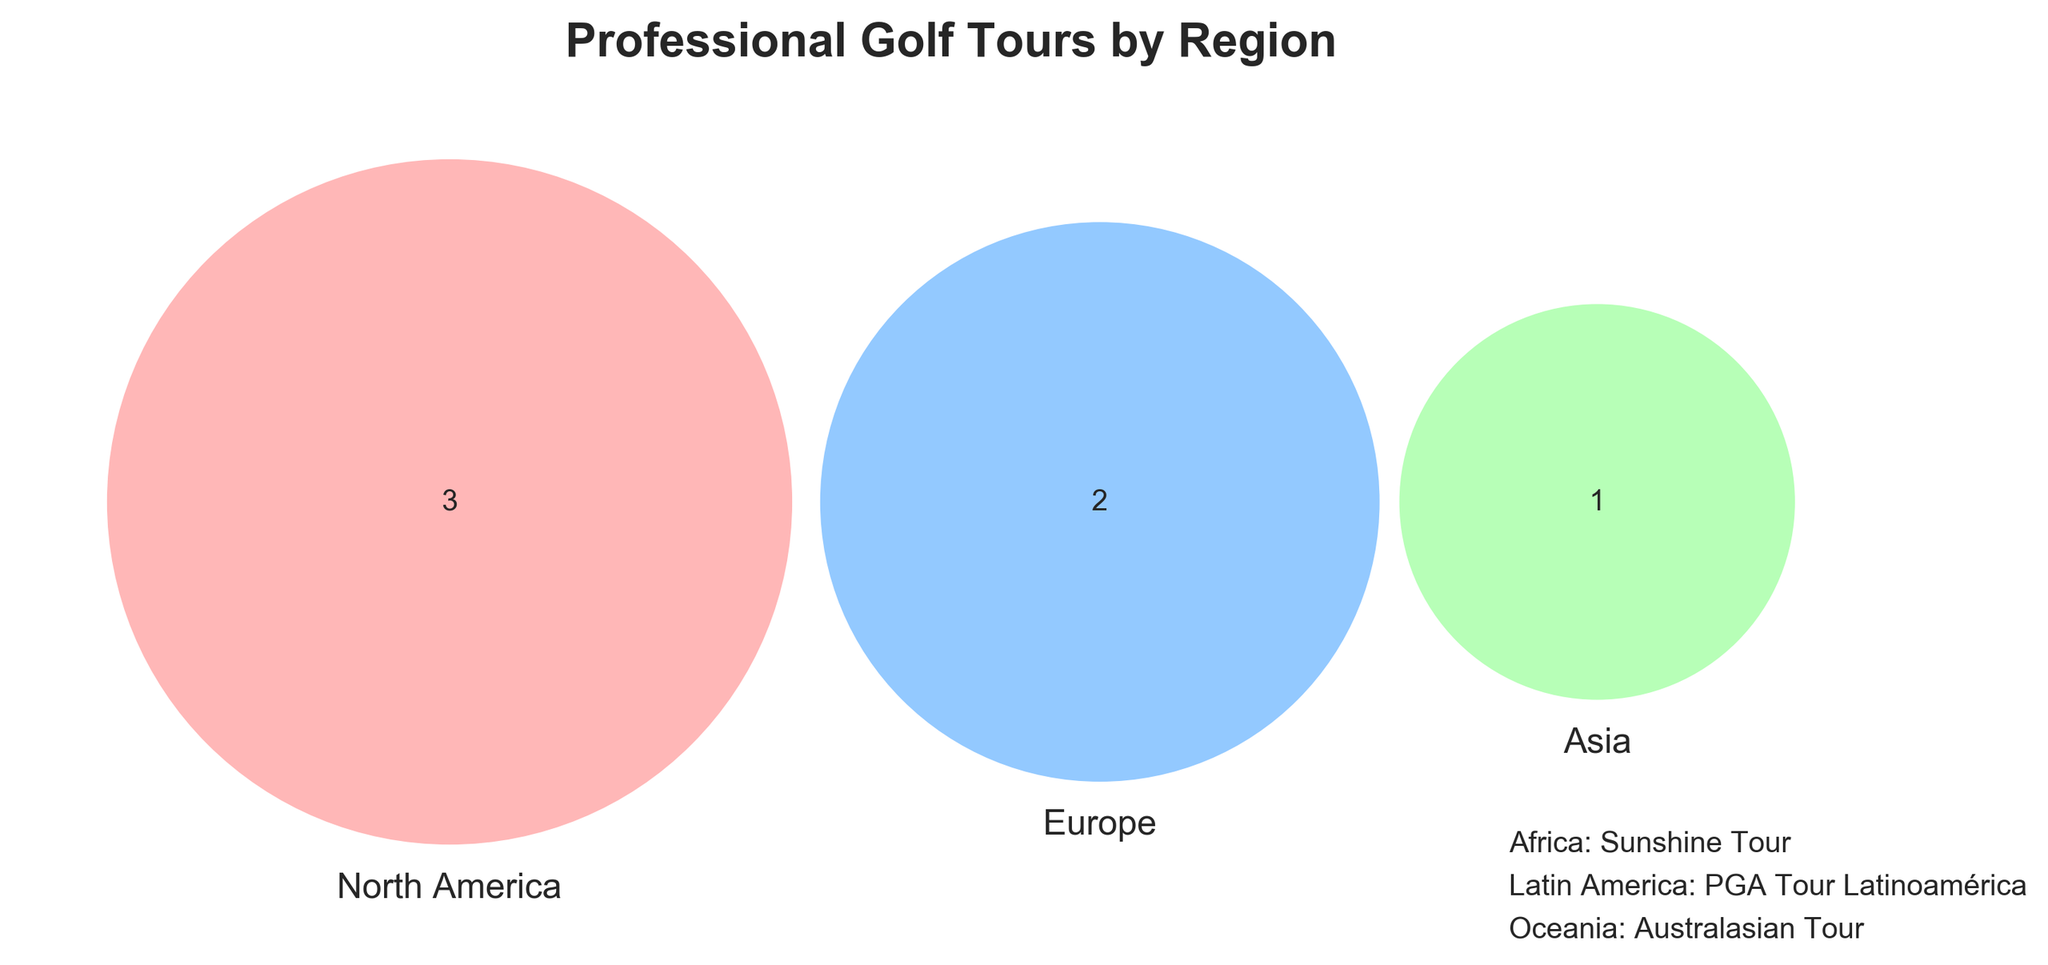What are the main three regions shown in the Venn diagram? The Venn diagram highlights three main regions, so we look at the title and set labels in the diagram.
Answer: North America, Europe, Asia Which region has the most number of tours listed? By observing the Venn diagram, we see which set (region) contains the most tours. This is North America with 3 tours: PGA Tour, PGA Tour Champions, and Korn Ferry Tour.
Answer: North America Which region does the Challenge Tour belong to? Challenge Tour's placement is checked by locating its corresponding region within the Venn diagram sets. Challenge Tour falls under the Europe set.
Answer: Europe Is there any tour that appears in both North America and Asia? Venn diagrams visually intersect sets, indicating common elements. By checking intersections, it is clear there is no overlap between North America and Asia in this diagram.
Answer: No How many tours belong to Europe? Count the elements present within the Europe set. The tours listed in Europe are the European Tour and Challenge Tour.
Answer: 2 What set of regions does the Australasian Tour belong to? Some tours and their regions are indicated outside the Venn diagram. Australasian Tour is mentioned in the additional text at the bottom right.
Answer: Oceania Are there any tours solely unique to Europe? Observe the tours listed exclusively within the Europe circle, without intersections with other regions' circles. Both European Tour and Challenge Tour are unique to Europe.
Answer: Yes Name a professional golf tour from Latin America mentioned in the diagram. Figure annotations outside the Venn diagram encompass additional regions. PGA Tour Latinoamérica is specified under Latin America.
Answer: PGA Tour Latinoamérica What is the set label for the pink color in the Venn diagram? Identify the color by visually inspecting the circles represented in the Venn diagram. The pink color represents North America.
Answer: North America Which regions share the least number of tours? By examining the overlaps, ascertain the region pairs with the fewest shared tours (in this case, no shared tours yield the least). Asia has no shared tours with either of the other regions North America or Europe.
Answer: Asia 